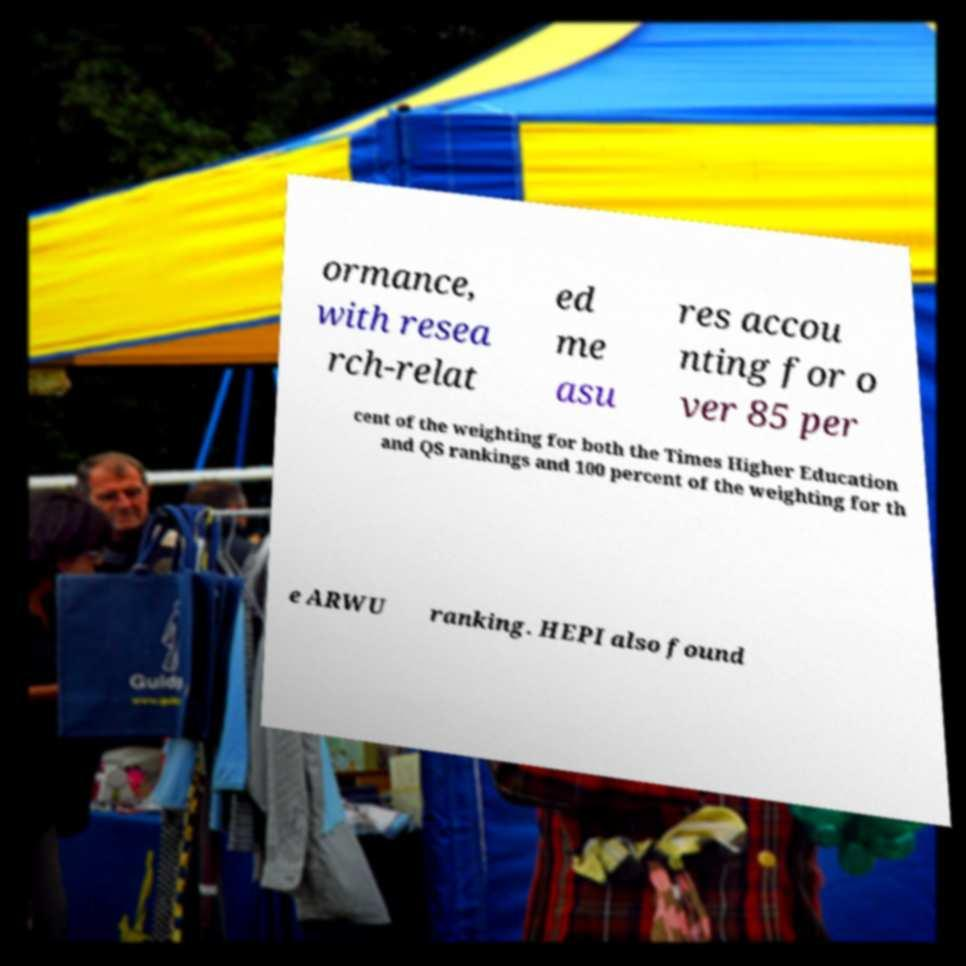Could you extract and type out the text from this image? ormance, with resea rch-relat ed me asu res accou nting for o ver 85 per cent of the weighting for both the Times Higher Education and QS rankings and 100 percent of the weighting for th e ARWU ranking. HEPI also found 